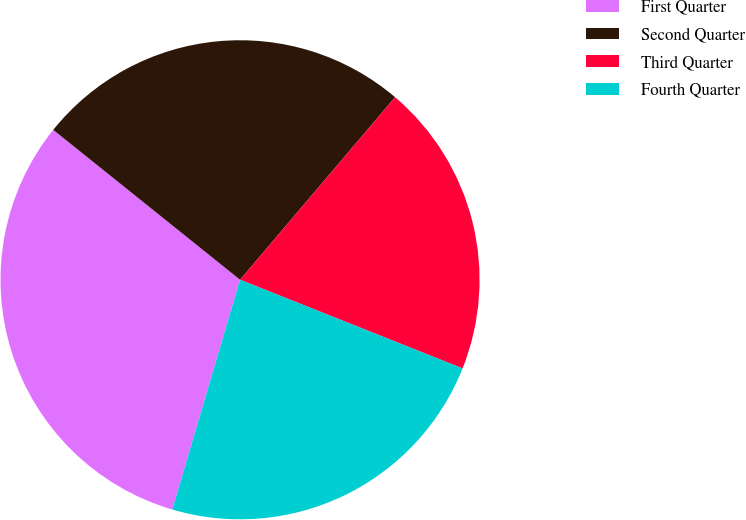Convert chart to OTSL. <chart><loc_0><loc_0><loc_500><loc_500><pie_chart><fcel>First Quarter<fcel>Second Quarter<fcel>Third Quarter<fcel>Fourth Quarter<nl><fcel>31.2%<fcel>25.44%<fcel>19.83%<fcel>23.53%<nl></chart> 